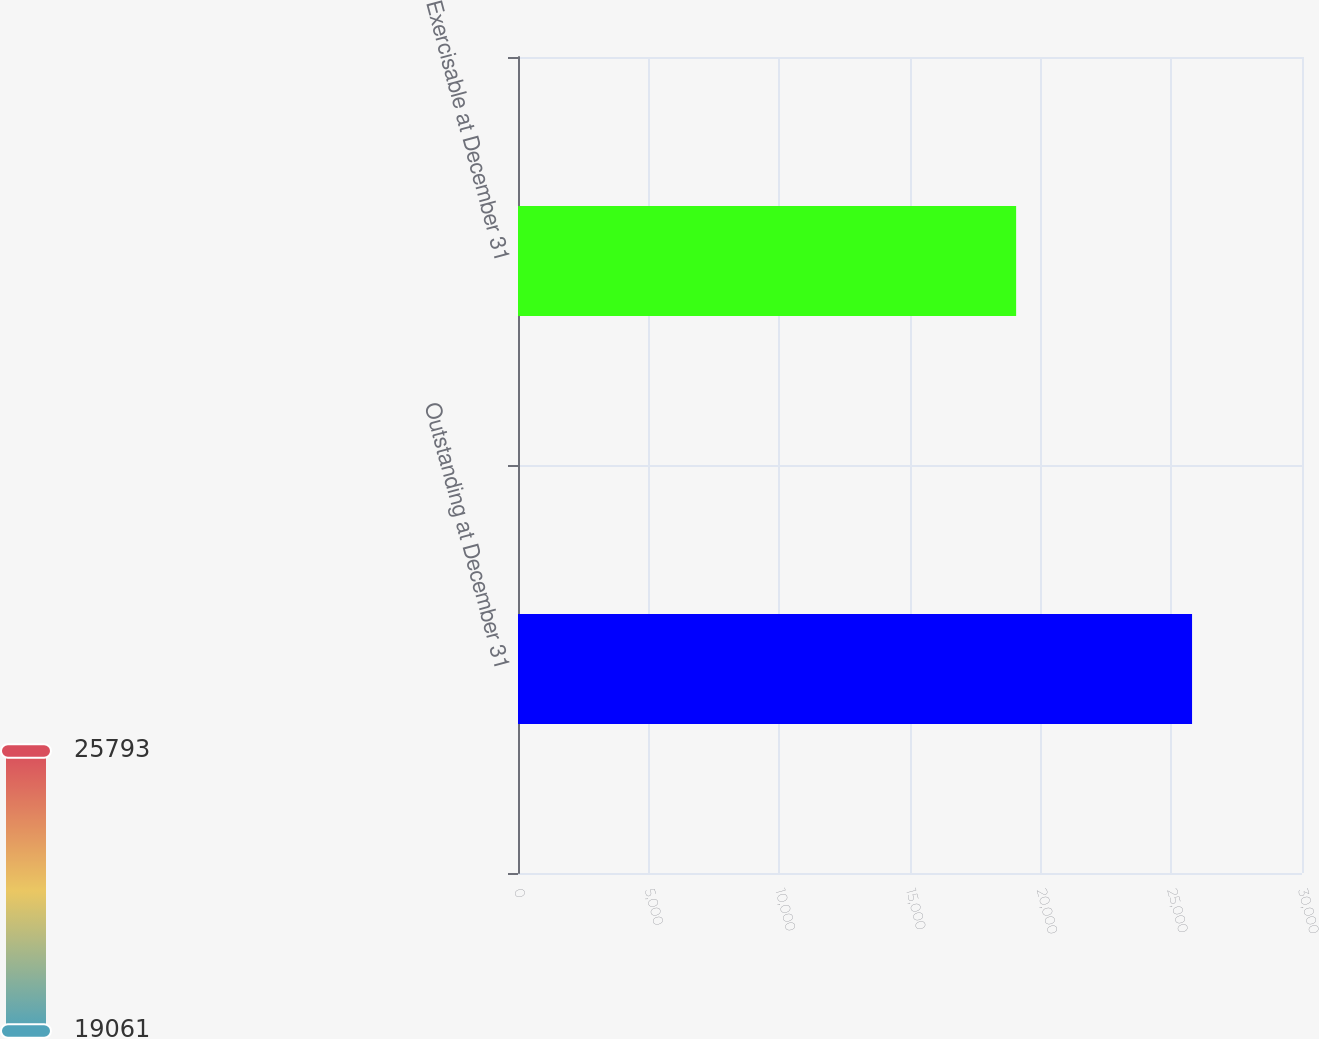Convert chart. <chart><loc_0><loc_0><loc_500><loc_500><bar_chart><fcel>Outstanding at December 31<fcel>Exercisable at December 31<nl><fcel>25793<fcel>19061<nl></chart> 